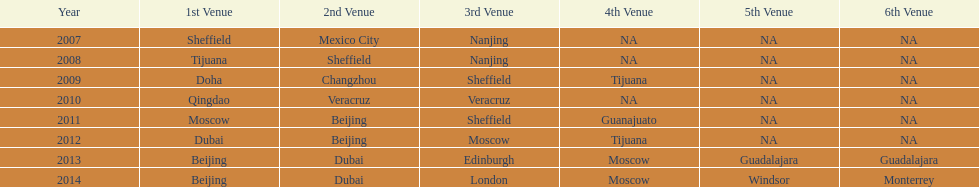Which year had more venues, 2007 or 2012? 2012. 